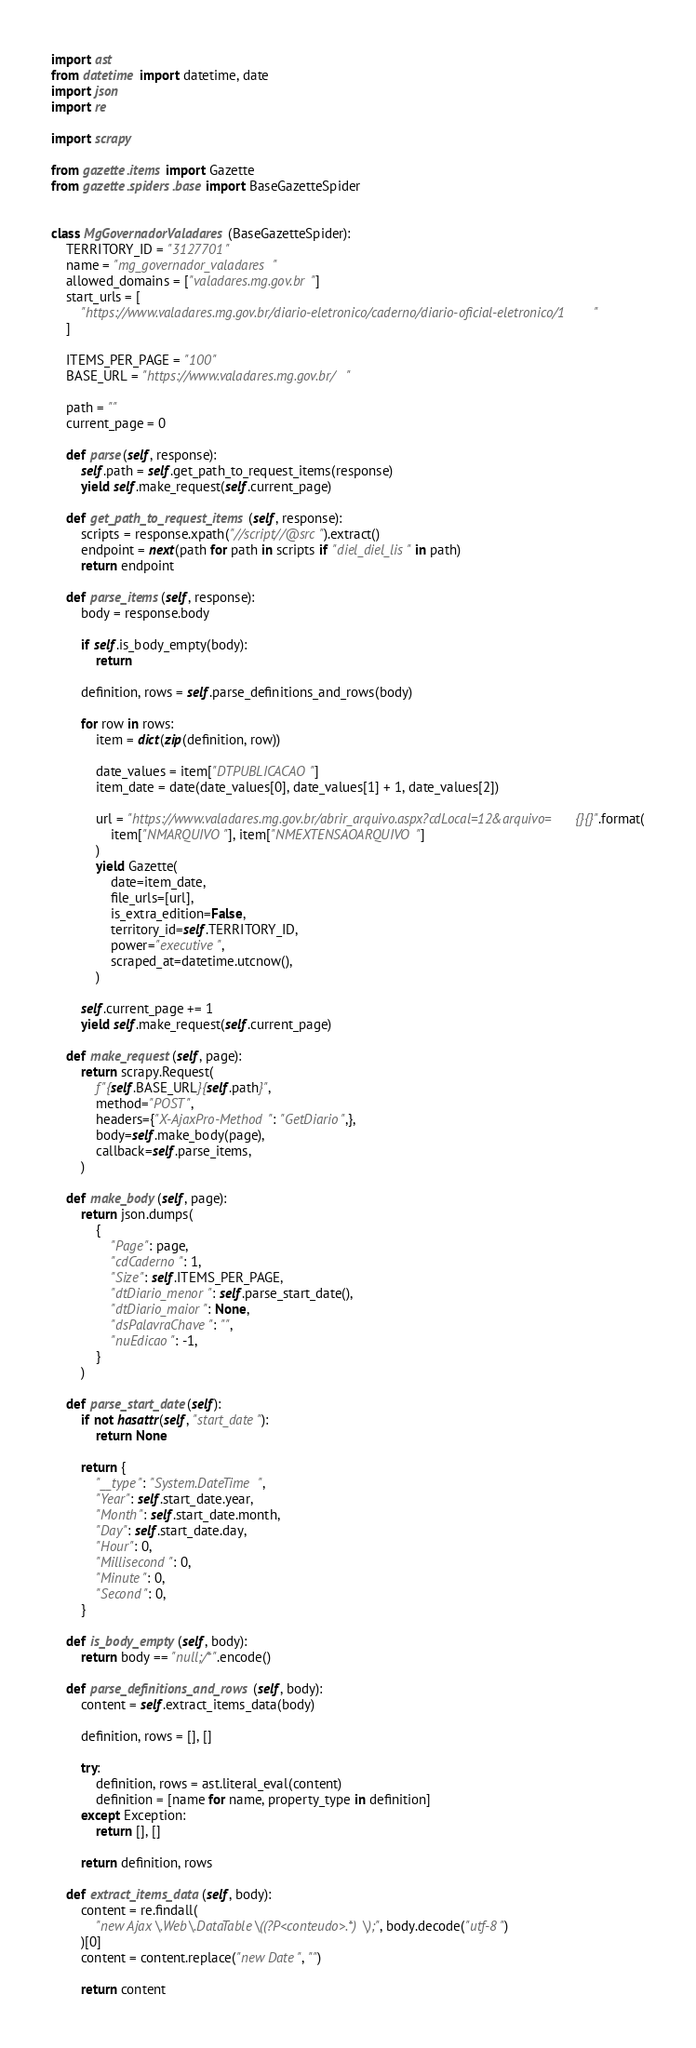Convert code to text. <code><loc_0><loc_0><loc_500><loc_500><_Python_>import ast
from datetime import datetime, date
import json
import re

import scrapy

from gazette.items import Gazette
from gazette.spiders.base import BaseGazetteSpider


class MgGovernadorValadares(BaseGazetteSpider):
    TERRITORY_ID = "3127701"
    name = "mg_governador_valadares"
    allowed_domains = ["valadares.mg.gov.br"]
    start_urls = [
        "https://www.valadares.mg.gov.br/diario-eletronico/caderno/diario-oficial-eletronico/1"
    ]

    ITEMS_PER_PAGE = "100"
    BASE_URL = "https://www.valadares.mg.gov.br/"

    path = ""
    current_page = 0

    def parse(self, response):
        self.path = self.get_path_to_request_items(response)
        yield self.make_request(self.current_page)

    def get_path_to_request_items(self, response):
        scripts = response.xpath("//script//@src").extract()
        endpoint = next(path for path in scripts if "diel_diel_lis" in path)
        return endpoint

    def parse_items(self, response):
        body = response.body

        if self.is_body_empty(body):
            return

        definition, rows = self.parse_definitions_and_rows(body)

        for row in rows:
            item = dict(zip(definition, row))

            date_values = item["DTPUBLICACAO"]
            item_date = date(date_values[0], date_values[1] + 1, date_values[2])

            url = "https://www.valadares.mg.gov.br/abrir_arquivo.aspx?cdLocal=12&arquivo={}{}".format(
                item["NMARQUIVO"], item["NMEXTENSAOARQUIVO"]
            )
            yield Gazette(
                date=item_date,
                file_urls=[url],
                is_extra_edition=False,
                territory_id=self.TERRITORY_ID,
                power="executive",
                scraped_at=datetime.utcnow(),
            )

        self.current_page += 1
        yield self.make_request(self.current_page)

    def make_request(self, page):
        return scrapy.Request(
            f"{self.BASE_URL}{self.path}",
            method="POST",
            headers={"X-AjaxPro-Method": "GetDiario",},
            body=self.make_body(page),
            callback=self.parse_items,
        )

    def make_body(self, page):
        return json.dumps(
            {
                "Page": page,
                "cdCaderno": 1,
                "Size": self.ITEMS_PER_PAGE,
                "dtDiario_menor": self.parse_start_date(),
                "dtDiario_maior": None,
                "dsPalavraChave": "",
                "nuEdicao": -1,
            }
        )

    def parse_start_date(self):
        if not hasattr(self, "start_date"):
            return None

        return {
            "__type": "System.DateTime",
            "Year": self.start_date.year,
            "Month": self.start_date.month,
            "Day": self.start_date.day,
            "Hour": 0,
            "Millisecond": 0,
            "Minute": 0,
            "Second": 0,
        }

    def is_body_empty(self, body):
        return body == "null;/*".encode()

    def parse_definitions_and_rows(self, body):
        content = self.extract_items_data(body)

        definition, rows = [], []

        try:
            definition, rows = ast.literal_eval(content)
            definition = [name for name, property_type in definition]
        except Exception:
            return [], []

        return definition, rows

    def extract_items_data(self, body):
        content = re.findall(
            "new Ajax\.Web\.DataTable\((?P<conteudo>.*)\);", body.decode("utf-8")
        )[0]
        content = content.replace("new Date", "")

        return content
</code> 